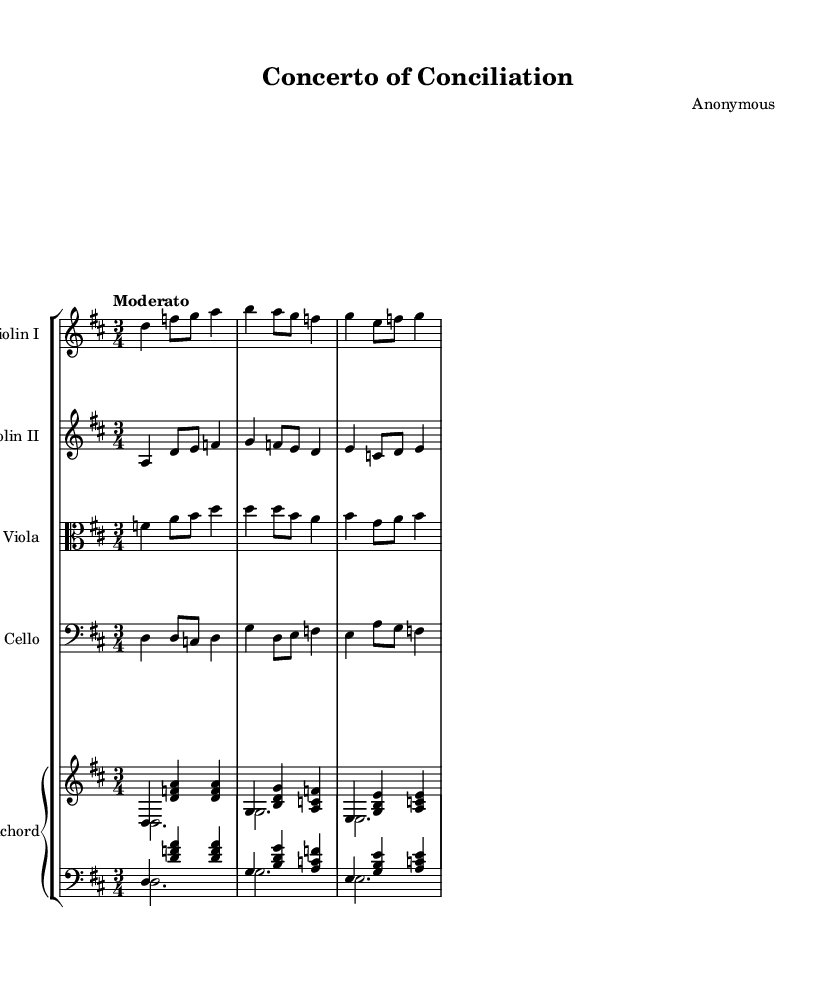What is the key signature of this music? The key signature is D major, which has two sharps (F# and C#). This can be determined by looking at the key signature indicator at the beginning of the score.
Answer: D major What is the time signature of this piece? The time signature is 3/4, which means there are three beats in each measure and the quarter note receives one beat. This can be identified in the opening measures of the score where the time signature is explicitly indicated.
Answer: 3/4 What is the tempo marking for this piece? The tempo marking is "Moderato," which indicates a moderate speed for the performance. This is noted clearly at the beginning of the score below the title.
Answer: Moderato Which instruments are featured in this chamber music? The featured instruments are two violins, viola, cello, and harpsichord. This can be seen in the instrumentation headings above each staff in the score.
Answer: Violin I, Violin II, Viola, Cello, Harpsichord How many measures does the first section of the piece contain? The first section of the piece contains 8 measures. By counting each measure from the beginning until the transition to the next thematic idea, we find a total of 8 distinct measures.
Answer: 8 Which instrument plays the bass line throughout the piece? The instrument that plays the bass line is the cello. This can be identified as the cello part consistently provides the foundational notes and often plays in the lower register, supporting the harmonic structure of the ensemble.
Answer: Cello What is the role of the harpsichord in this composition? The harpsichord serves as both a solo and accompaniment instrument, providing harmonic support and articulation while also being featured prominently alongside the strings. This can be interpreted by analyzing the score, where the harpsichord part contains both chords and independent melodic lines.
Answer: Accompaniment and solo 